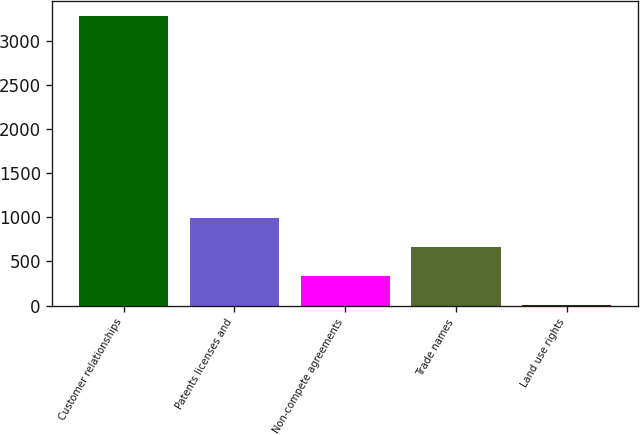Convert chart to OTSL. <chart><loc_0><loc_0><loc_500><loc_500><bar_chart><fcel>Customer relationships<fcel>Patents licenses and<fcel>Non-compete agreements<fcel>Trade names<fcel>Land use rights<nl><fcel>3283<fcel>990.71<fcel>335.77<fcel>663.24<fcel>8.3<nl></chart> 